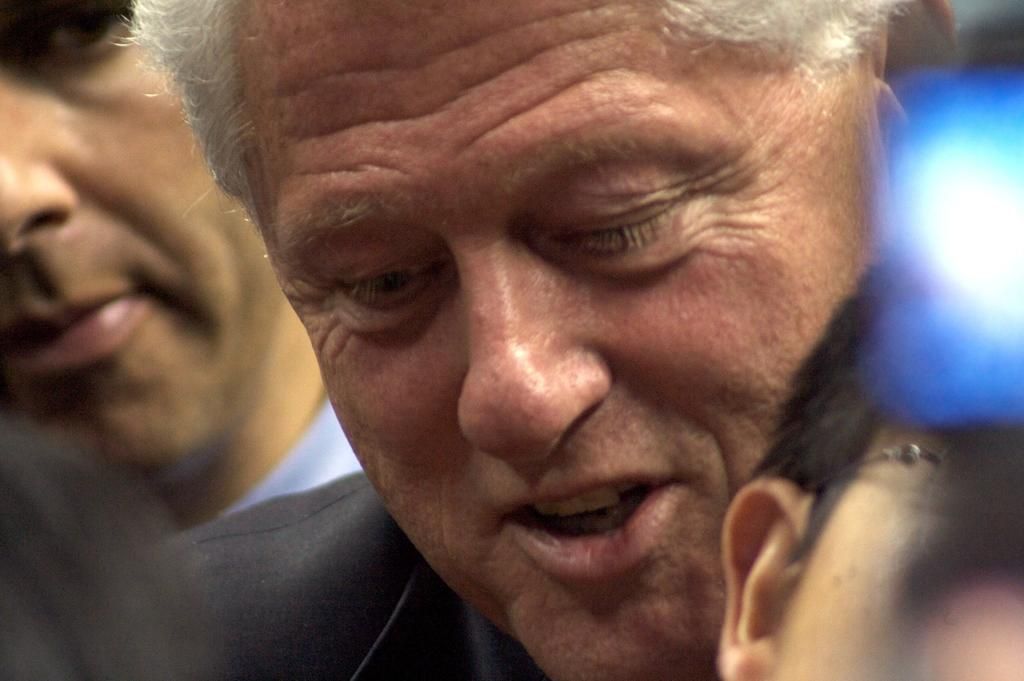How many people are in the image? The number of people in the image is not specified, but there are persons present. Can you describe any objects in the image? Yes, there is an object that looks like a light on the right side of the image. What type of stew is being prepared by the persons in the image? There is no indication of any stew or cooking activity in the image. 